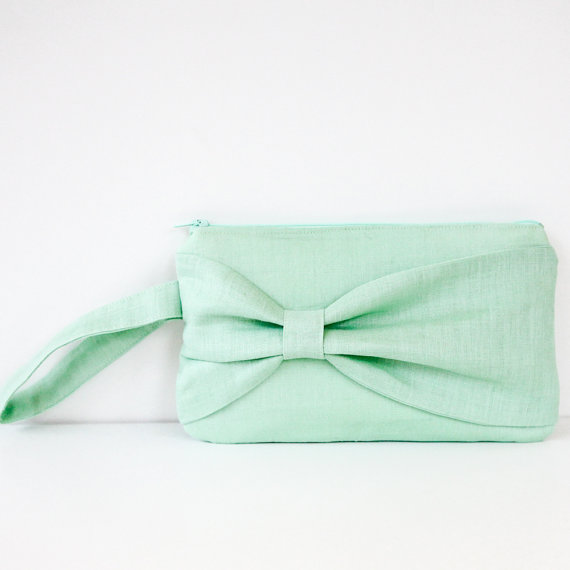Given the design and color of the clutch purse, what type of event or setting might it be most suitable for, and why? The clutch purse, featuring a soothing mint green color and a sophisticated decorative bow, is ideally suited for spring or summer events. Its pastel hue and elegant design make it an excellent choice for semi-formal or dressy casual occasions such as weddings, garden parties, or daytime social gatherings. The wrist strap not only adds a touch of practicality, allowing for ease of carrying, but also ensures it complements the breezy atmosphere of outdoor events like cocktail receptions or picnics. The light, refreshing color and charming bow detail make it a perfect accessory to enhance a stylish ensemble. 